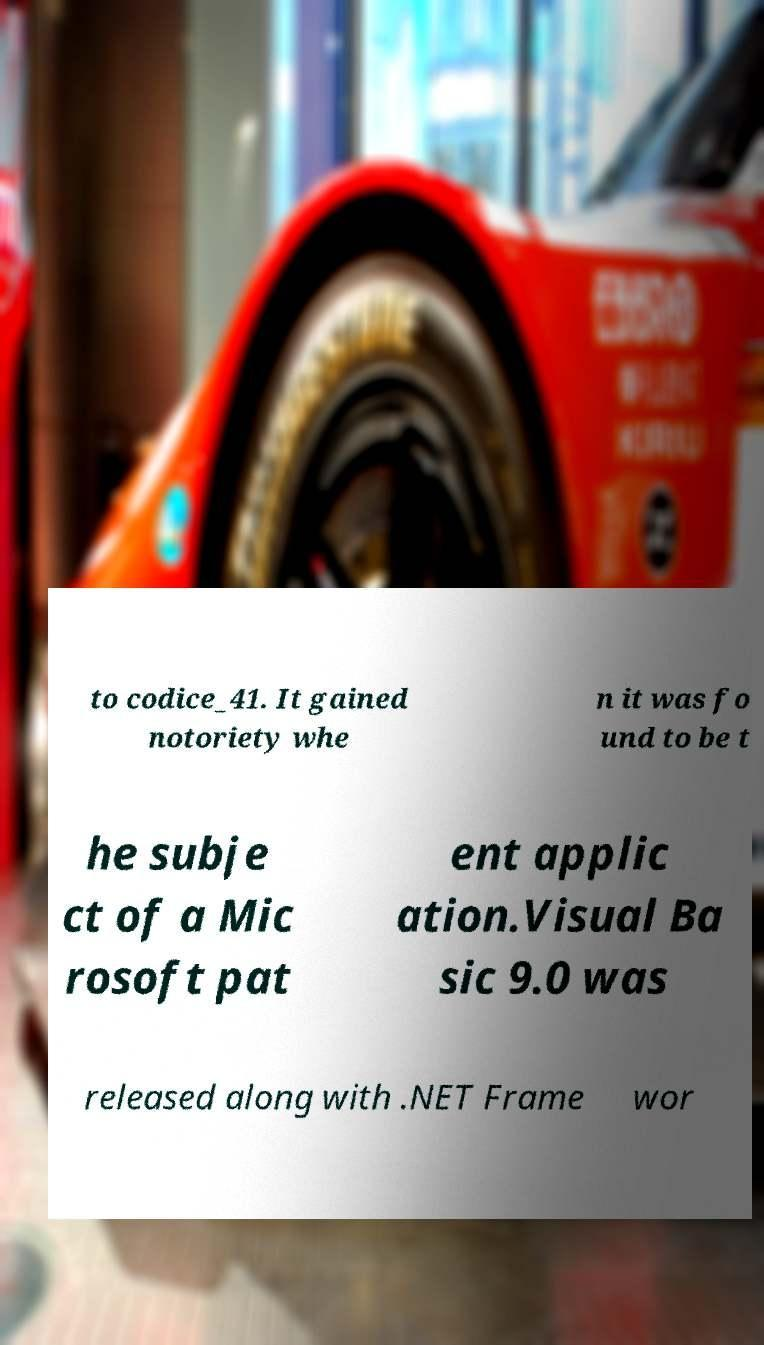What messages or text are displayed in this image? I need them in a readable, typed format. to codice_41. It gained notoriety whe n it was fo und to be t he subje ct of a Mic rosoft pat ent applic ation.Visual Ba sic 9.0 was released along with .NET Frame wor 